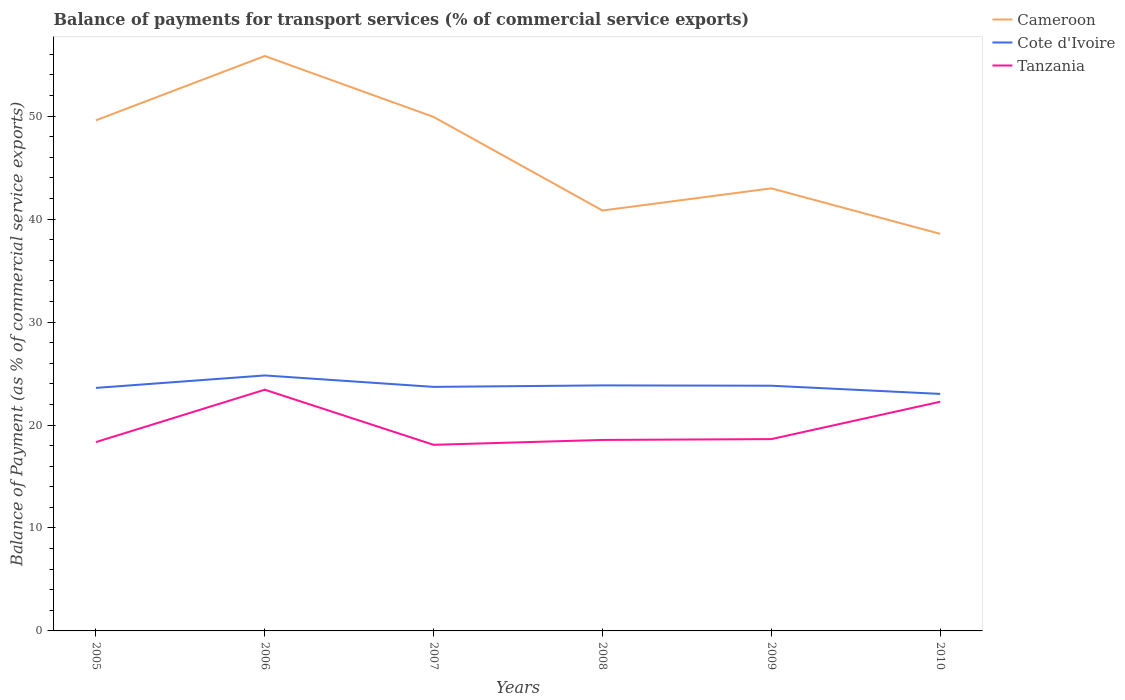Is the number of lines equal to the number of legend labels?
Your answer should be compact. Yes. Across all years, what is the maximum balance of payments for transport services in Cameroon?
Keep it short and to the point. 38.57. What is the total balance of payments for transport services in Cote d'Ivoire in the graph?
Offer a very short reply. 0.97. What is the difference between the highest and the second highest balance of payments for transport services in Cote d'Ivoire?
Provide a short and direct response. 1.79. Is the balance of payments for transport services in Cote d'Ivoire strictly greater than the balance of payments for transport services in Tanzania over the years?
Give a very brief answer. No. Are the values on the major ticks of Y-axis written in scientific E-notation?
Give a very brief answer. No. Does the graph contain grids?
Provide a succinct answer. No. Where does the legend appear in the graph?
Keep it short and to the point. Top right. How are the legend labels stacked?
Your answer should be very brief. Vertical. What is the title of the graph?
Ensure brevity in your answer.  Balance of payments for transport services (% of commercial service exports). What is the label or title of the Y-axis?
Your response must be concise. Balance of Payment (as % of commercial service exports). What is the Balance of Payment (as % of commercial service exports) of Cameroon in 2005?
Your answer should be very brief. 49.59. What is the Balance of Payment (as % of commercial service exports) in Cote d'Ivoire in 2005?
Offer a very short reply. 23.6. What is the Balance of Payment (as % of commercial service exports) in Tanzania in 2005?
Your answer should be very brief. 18.34. What is the Balance of Payment (as % of commercial service exports) of Cameroon in 2006?
Offer a terse response. 55.84. What is the Balance of Payment (as % of commercial service exports) of Cote d'Ivoire in 2006?
Make the answer very short. 24.81. What is the Balance of Payment (as % of commercial service exports) of Tanzania in 2006?
Ensure brevity in your answer.  23.43. What is the Balance of Payment (as % of commercial service exports) in Cameroon in 2007?
Provide a succinct answer. 49.92. What is the Balance of Payment (as % of commercial service exports) of Cote d'Ivoire in 2007?
Provide a succinct answer. 23.7. What is the Balance of Payment (as % of commercial service exports) in Tanzania in 2007?
Your answer should be compact. 18.08. What is the Balance of Payment (as % of commercial service exports) in Cameroon in 2008?
Make the answer very short. 40.83. What is the Balance of Payment (as % of commercial service exports) in Cote d'Ivoire in 2008?
Offer a very short reply. 23.85. What is the Balance of Payment (as % of commercial service exports) of Tanzania in 2008?
Ensure brevity in your answer.  18.55. What is the Balance of Payment (as % of commercial service exports) of Cameroon in 2009?
Your answer should be very brief. 42.99. What is the Balance of Payment (as % of commercial service exports) of Cote d'Ivoire in 2009?
Keep it short and to the point. 23.82. What is the Balance of Payment (as % of commercial service exports) in Tanzania in 2009?
Provide a short and direct response. 18.63. What is the Balance of Payment (as % of commercial service exports) of Cameroon in 2010?
Your answer should be very brief. 38.57. What is the Balance of Payment (as % of commercial service exports) of Cote d'Ivoire in 2010?
Your answer should be very brief. 23.02. What is the Balance of Payment (as % of commercial service exports) in Tanzania in 2010?
Keep it short and to the point. 22.26. Across all years, what is the maximum Balance of Payment (as % of commercial service exports) in Cameroon?
Provide a short and direct response. 55.84. Across all years, what is the maximum Balance of Payment (as % of commercial service exports) of Cote d'Ivoire?
Ensure brevity in your answer.  24.81. Across all years, what is the maximum Balance of Payment (as % of commercial service exports) in Tanzania?
Your response must be concise. 23.43. Across all years, what is the minimum Balance of Payment (as % of commercial service exports) in Cameroon?
Your answer should be compact. 38.57. Across all years, what is the minimum Balance of Payment (as % of commercial service exports) in Cote d'Ivoire?
Give a very brief answer. 23.02. Across all years, what is the minimum Balance of Payment (as % of commercial service exports) of Tanzania?
Offer a terse response. 18.08. What is the total Balance of Payment (as % of commercial service exports) in Cameroon in the graph?
Give a very brief answer. 277.74. What is the total Balance of Payment (as % of commercial service exports) in Cote d'Ivoire in the graph?
Offer a terse response. 142.81. What is the total Balance of Payment (as % of commercial service exports) of Tanzania in the graph?
Your answer should be very brief. 119.29. What is the difference between the Balance of Payment (as % of commercial service exports) of Cameroon in 2005 and that in 2006?
Make the answer very short. -6.24. What is the difference between the Balance of Payment (as % of commercial service exports) of Cote d'Ivoire in 2005 and that in 2006?
Give a very brief answer. -1.21. What is the difference between the Balance of Payment (as % of commercial service exports) of Tanzania in 2005 and that in 2006?
Your answer should be compact. -5.09. What is the difference between the Balance of Payment (as % of commercial service exports) in Cameroon in 2005 and that in 2007?
Give a very brief answer. -0.33. What is the difference between the Balance of Payment (as % of commercial service exports) in Cote d'Ivoire in 2005 and that in 2007?
Your answer should be very brief. -0.1. What is the difference between the Balance of Payment (as % of commercial service exports) in Tanzania in 2005 and that in 2007?
Your response must be concise. 0.27. What is the difference between the Balance of Payment (as % of commercial service exports) in Cameroon in 2005 and that in 2008?
Your answer should be very brief. 8.76. What is the difference between the Balance of Payment (as % of commercial service exports) of Cote d'Ivoire in 2005 and that in 2008?
Make the answer very short. -0.24. What is the difference between the Balance of Payment (as % of commercial service exports) in Tanzania in 2005 and that in 2008?
Make the answer very short. -0.21. What is the difference between the Balance of Payment (as % of commercial service exports) in Cameroon in 2005 and that in 2009?
Your answer should be very brief. 6.61. What is the difference between the Balance of Payment (as % of commercial service exports) in Cote d'Ivoire in 2005 and that in 2009?
Your answer should be very brief. -0.21. What is the difference between the Balance of Payment (as % of commercial service exports) of Tanzania in 2005 and that in 2009?
Offer a very short reply. -0.29. What is the difference between the Balance of Payment (as % of commercial service exports) of Cameroon in 2005 and that in 2010?
Give a very brief answer. 11.03. What is the difference between the Balance of Payment (as % of commercial service exports) in Cote d'Ivoire in 2005 and that in 2010?
Provide a succinct answer. 0.58. What is the difference between the Balance of Payment (as % of commercial service exports) of Tanzania in 2005 and that in 2010?
Keep it short and to the point. -3.92. What is the difference between the Balance of Payment (as % of commercial service exports) in Cameroon in 2006 and that in 2007?
Ensure brevity in your answer.  5.92. What is the difference between the Balance of Payment (as % of commercial service exports) of Cote d'Ivoire in 2006 and that in 2007?
Provide a short and direct response. 1.11. What is the difference between the Balance of Payment (as % of commercial service exports) of Tanzania in 2006 and that in 2007?
Your answer should be compact. 5.35. What is the difference between the Balance of Payment (as % of commercial service exports) of Cameroon in 2006 and that in 2008?
Keep it short and to the point. 15.01. What is the difference between the Balance of Payment (as % of commercial service exports) of Cote d'Ivoire in 2006 and that in 2008?
Offer a terse response. 0.97. What is the difference between the Balance of Payment (as % of commercial service exports) of Tanzania in 2006 and that in 2008?
Provide a short and direct response. 4.88. What is the difference between the Balance of Payment (as % of commercial service exports) in Cameroon in 2006 and that in 2009?
Your answer should be compact. 12.85. What is the difference between the Balance of Payment (as % of commercial service exports) of Cote d'Ivoire in 2006 and that in 2009?
Offer a terse response. 1. What is the difference between the Balance of Payment (as % of commercial service exports) in Tanzania in 2006 and that in 2009?
Your answer should be very brief. 4.8. What is the difference between the Balance of Payment (as % of commercial service exports) of Cameroon in 2006 and that in 2010?
Provide a short and direct response. 17.27. What is the difference between the Balance of Payment (as % of commercial service exports) in Cote d'Ivoire in 2006 and that in 2010?
Provide a short and direct response. 1.79. What is the difference between the Balance of Payment (as % of commercial service exports) of Tanzania in 2006 and that in 2010?
Give a very brief answer. 1.17. What is the difference between the Balance of Payment (as % of commercial service exports) of Cameroon in 2007 and that in 2008?
Your response must be concise. 9.09. What is the difference between the Balance of Payment (as % of commercial service exports) of Cote d'Ivoire in 2007 and that in 2008?
Make the answer very short. -0.14. What is the difference between the Balance of Payment (as % of commercial service exports) in Tanzania in 2007 and that in 2008?
Offer a very short reply. -0.47. What is the difference between the Balance of Payment (as % of commercial service exports) in Cameroon in 2007 and that in 2009?
Ensure brevity in your answer.  6.94. What is the difference between the Balance of Payment (as % of commercial service exports) of Cote d'Ivoire in 2007 and that in 2009?
Your answer should be very brief. -0.11. What is the difference between the Balance of Payment (as % of commercial service exports) in Tanzania in 2007 and that in 2009?
Offer a terse response. -0.55. What is the difference between the Balance of Payment (as % of commercial service exports) in Cameroon in 2007 and that in 2010?
Offer a very short reply. 11.36. What is the difference between the Balance of Payment (as % of commercial service exports) of Cote d'Ivoire in 2007 and that in 2010?
Make the answer very short. 0.68. What is the difference between the Balance of Payment (as % of commercial service exports) of Tanzania in 2007 and that in 2010?
Your answer should be very brief. -4.18. What is the difference between the Balance of Payment (as % of commercial service exports) of Cameroon in 2008 and that in 2009?
Your answer should be very brief. -2.15. What is the difference between the Balance of Payment (as % of commercial service exports) in Cote d'Ivoire in 2008 and that in 2009?
Keep it short and to the point. 0.03. What is the difference between the Balance of Payment (as % of commercial service exports) in Tanzania in 2008 and that in 2009?
Offer a terse response. -0.08. What is the difference between the Balance of Payment (as % of commercial service exports) in Cameroon in 2008 and that in 2010?
Your answer should be very brief. 2.27. What is the difference between the Balance of Payment (as % of commercial service exports) in Cote d'Ivoire in 2008 and that in 2010?
Offer a terse response. 0.83. What is the difference between the Balance of Payment (as % of commercial service exports) in Tanzania in 2008 and that in 2010?
Keep it short and to the point. -3.71. What is the difference between the Balance of Payment (as % of commercial service exports) in Cameroon in 2009 and that in 2010?
Ensure brevity in your answer.  4.42. What is the difference between the Balance of Payment (as % of commercial service exports) of Cote d'Ivoire in 2009 and that in 2010?
Offer a very short reply. 0.79. What is the difference between the Balance of Payment (as % of commercial service exports) of Tanzania in 2009 and that in 2010?
Offer a very short reply. -3.63. What is the difference between the Balance of Payment (as % of commercial service exports) of Cameroon in 2005 and the Balance of Payment (as % of commercial service exports) of Cote d'Ivoire in 2006?
Provide a short and direct response. 24.78. What is the difference between the Balance of Payment (as % of commercial service exports) of Cameroon in 2005 and the Balance of Payment (as % of commercial service exports) of Tanzania in 2006?
Offer a very short reply. 26.17. What is the difference between the Balance of Payment (as % of commercial service exports) of Cote d'Ivoire in 2005 and the Balance of Payment (as % of commercial service exports) of Tanzania in 2006?
Keep it short and to the point. 0.17. What is the difference between the Balance of Payment (as % of commercial service exports) in Cameroon in 2005 and the Balance of Payment (as % of commercial service exports) in Cote d'Ivoire in 2007?
Make the answer very short. 25.89. What is the difference between the Balance of Payment (as % of commercial service exports) of Cameroon in 2005 and the Balance of Payment (as % of commercial service exports) of Tanzania in 2007?
Provide a short and direct response. 31.52. What is the difference between the Balance of Payment (as % of commercial service exports) of Cote d'Ivoire in 2005 and the Balance of Payment (as % of commercial service exports) of Tanzania in 2007?
Make the answer very short. 5.53. What is the difference between the Balance of Payment (as % of commercial service exports) in Cameroon in 2005 and the Balance of Payment (as % of commercial service exports) in Cote d'Ivoire in 2008?
Provide a short and direct response. 25.75. What is the difference between the Balance of Payment (as % of commercial service exports) of Cameroon in 2005 and the Balance of Payment (as % of commercial service exports) of Tanzania in 2008?
Your response must be concise. 31.04. What is the difference between the Balance of Payment (as % of commercial service exports) in Cote d'Ivoire in 2005 and the Balance of Payment (as % of commercial service exports) in Tanzania in 2008?
Offer a very short reply. 5.05. What is the difference between the Balance of Payment (as % of commercial service exports) of Cameroon in 2005 and the Balance of Payment (as % of commercial service exports) of Cote d'Ivoire in 2009?
Your answer should be very brief. 25.78. What is the difference between the Balance of Payment (as % of commercial service exports) of Cameroon in 2005 and the Balance of Payment (as % of commercial service exports) of Tanzania in 2009?
Offer a very short reply. 30.96. What is the difference between the Balance of Payment (as % of commercial service exports) in Cote d'Ivoire in 2005 and the Balance of Payment (as % of commercial service exports) in Tanzania in 2009?
Ensure brevity in your answer.  4.97. What is the difference between the Balance of Payment (as % of commercial service exports) of Cameroon in 2005 and the Balance of Payment (as % of commercial service exports) of Cote d'Ivoire in 2010?
Ensure brevity in your answer.  26.57. What is the difference between the Balance of Payment (as % of commercial service exports) in Cameroon in 2005 and the Balance of Payment (as % of commercial service exports) in Tanzania in 2010?
Offer a very short reply. 27.33. What is the difference between the Balance of Payment (as % of commercial service exports) in Cote d'Ivoire in 2005 and the Balance of Payment (as % of commercial service exports) in Tanzania in 2010?
Offer a terse response. 1.34. What is the difference between the Balance of Payment (as % of commercial service exports) of Cameroon in 2006 and the Balance of Payment (as % of commercial service exports) of Cote d'Ivoire in 2007?
Keep it short and to the point. 32.14. What is the difference between the Balance of Payment (as % of commercial service exports) of Cameroon in 2006 and the Balance of Payment (as % of commercial service exports) of Tanzania in 2007?
Offer a terse response. 37.76. What is the difference between the Balance of Payment (as % of commercial service exports) in Cote d'Ivoire in 2006 and the Balance of Payment (as % of commercial service exports) in Tanzania in 2007?
Provide a succinct answer. 6.74. What is the difference between the Balance of Payment (as % of commercial service exports) in Cameroon in 2006 and the Balance of Payment (as % of commercial service exports) in Cote d'Ivoire in 2008?
Your response must be concise. 31.99. What is the difference between the Balance of Payment (as % of commercial service exports) in Cameroon in 2006 and the Balance of Payment (as % of commercial service exports) in Tanzania in 2008?
Give a very brief answer. 37.29. What is the difference between the Balance of Payment (as % of commercial service exports) in Cote d'Ivoire in 2006 and the Balance of Payment (as % of commercial service exports) in Tanzania in 2008?
Offer a very short reply. 6.26. What is the difference between the Balance of Payment (as % of commercial service exports) in Cameroon in 2006 and the Balance of Payment (as % of commercial service exports) in Cote d'Ivoire in 2009?
Provide a short and direct response. 32.02. What is the difference between the Balance of Payment (as % of commercial service exports) of Cameroon in 2006 and the Balance of Payment (as % of commercial service exports) of Tanzania in 2009?
Your answer should be compact. 37.21. What is the difference between the Balance of Payment (as % of commercial service exports) of Cote d'Ivoire in 2006 and the Balance of Payment (as % of commercial service exports) of Tanzania in 2009?
Your answer should be very brief. 6.18. What is the difference between the Balance of Payment (as % of commercial service exports) of Cameroon in 2006 and the Balance of Payment (as % of commercial service exports) of Cote d'Ivoire in 2010?
Ensure brevity in your answer.  32.82. What is the difference between the Balance of Payment (as % of commercial service exports) of Cameroon in 2006 and the Balance of Payment (as % of commercial service exports) of Tanzania in 2010?
Make the answer very short. 33.58. What is the difference between the Balance of Payment (as % of commercial service exports) in Cote d'Ivoire in 2006 and the Balance of Payment (as % of commercial service exports) in Tanzania in 2010?
Your response must be concise. 2.55. What is the difference between the Balance of Payment (as % of commercial service exports) of Cameroon in 2007 and the Balance of Payment (as % of commercial service exports) of Cote d'Ivoire in 2008?
Your response must be concise. 26.07. What is the difference between the Balance of Payment (as % of commercial service exports) in Cameroon in 2007 and the Balance of Payment (as % of commercial service exports) in Tanzania in 2008?
Offer a terse response. 31.37. What is the difference between the Balance of Payment (as % of commercial service exports) in Cote d'Ivoire in 2007 and the Balance of Payment (as % of commercial service exports) in Tanzania in 2008?
Ensure brevity in your answer.  5.15. What is the difference between the Balance of Payment (as % of commercial service exports) in Cameroon in 2007 and the Balance of Payment (as % of commercial service exports) in Cote d'Ivoire in 2009?
Your response must be concise. 26.11. What is the difference between the Balance of Payment (as % of commercial service exports) in Cameroon in 2007 and the Balance of Payment (as % of commercial service exports) in Tanzania in 2009?
Your answer should be compact. 31.29. What is the difference between the Balance of Payment (as % of commercial service exports) in Cote d'Ivoire in 2007 and the Balance of Payment (as % of commercial service exports) in Tanzania in 2009?
Ensure brevity in your answer.  5.07. What is the difference between the Balance of Payment (as % of commercial service exports) in Cameroon in 2007 and the Balance of Payment (as % of commercial service exports) in Cote d'Ivoire in 2010?
Offer a very short reply. 26.9. What is the difference between the Balance of Payment (as % of commercial service exports) in Cameroon in 2007 and the Balance of Payment (as % of commercial service exports) in Tanzania in 2010?
Make the answer very short. 27.66. What is the difference between the Balance of Payment (as % of commercial service exports) in Cote d'Ivoire in 2007 and the Balance of Payment (as % of commercial service exports) in Tanzania in 2010?
Your answer should be very brief. 1.44. What is the difference between the Balance of Payment (as % of commercial service exports) in Cameroon in 2008 and the Balance of Payment (as % of commercial service exports) in Cote d'Ivoire in 2009?
Give a very brief answer. 17.02. What is the difference between the Balance of Payment (as % of commercial service exports) of Cameroon in 2008 and the Balance of Payment (as % of commercial service exports) of Tanzania in 2009?
Your response must be concise. 22.2. What is the difference between the Balance of Payment (as % of commercial service exports) of Cote d'Ivoire in 2008 and the Balance of Payment (as % of commercial service exports) of Tanzania in 2009?
Ensure brevity in your answer.  5.22. What is the difference between the Balance of Payment (as % of commercial service exports) of Cameroon in 2008 and the Balance of Payment (as % of commercial service exports) of Cote d'Ivoire in 2010?
Provide a succinct answer. 17.81. What is the difference between the Balance of Payment (as % of commercial service exports) of Cameroon in 2008 and the Balance of Payment (as % of commercial service exports) of Tanzania in 2010?
Ensure brevity in your answer.  18.57. What is the difference between the Balance of Payment (as % of commercial service exports) of Cote d'Ivoire in 2008 and the Balance of Payment (as % of commercial service exports) of Tanzania in 2010?
Provide a succinct answer. 1.59. What is the difference between the Balance of Payment (as % of commercial service exports) of Cameroon in 2009 and the Balance of Payment (as % of commercial service exports) of Cote d'Ivoire in 2010?
Provide a short and direct response. 19.96. What is the difference between the Balance of Payment (as % of commercial service exports) in Cameroon in 2009 and the Balance of Payment (as % of commercial service exports) in Tanzania in 2010?
Offer a terse response. 20.73. What is the difference between the Balance of Payment (as % of commercial service exports) in Cote d'Ivoire in 2009 and the Balance of Payment (as % of commercial service exports) in Tanzania in 2010?
Your answer should be very brief. 1.56. What is the average Balance of Payment (as % of commercial service exports) of Cameroon per year?
Provide a short and direct response. 46.29. What is the average Balance of Payment (as % of commercial service exports) in Cote d'Ivoire per year?
Keep it short and to the point. 23.8. What is the average Balance of Payment (as % of commercial service exports) in Tanzania per year?
Offer a terse response. 19.88. In the year 2005, what is the difference between the Balance of Payment (as % of commercial service exports) in Cameroon and Balance of Payment (as % of commercial service exports) in Cote d'Ivoire?
Your answer should be very brief. 25.99. In the year 2005, what is the difference between the Balance of Payment (as % of commercial service exports) of Cameroon and Balance of Payment (as % of commercial service exports) of Tanzania?
Your response must be concise. 31.25. In the year 2005, what is the difference between the Balance of Payment (as % of commercial service exports) in Cote d'Ivoire and Balance of Payment (as % of commercial service exports) in Tanzania?
Ensure brevity in your answer.  5.26. In the year 2006, what is the difference between the Balance of Payment (as % of commercial service exports) in Cameroon and Balance of Payment (as % of commercial service exports) in Cote d'Ivoire?
Give a very brief answer. 31.02. In the year 2006, what is the difference between the Balance of Payment (as % of commercial service exports) in Cameroon and Balance of Payment (as % of commercial service exports) in Tanzania?
Your answer should be very brief. 32.41. In the year 2006, what is the difference between the Balance of Payment (as % of commercial service exports) in Cote d'Ivoire and Balance of Payment (as % of commercial service exports) in Tanzania?
Your answer should be compact. 1.39. In the year 2007, what is the difference between the Balance of Payment (as % of commercial service exports) in Cameroon and Balance of Payment (as % of commercial service exports) in Cote d'Ivoire?
Offer a terse response. 26.22. In the year 2007, what is the difference between the Balance of Payment (as % of commercial service exports) of Cameroon and Balance of Payment (as % of commercial service exports) of Tanzania?
Make the answer very short. 31.85. In the year 2007, what is the difference between the Balance of Payment (as % of commercial service exports) of Cote d'Ivoire and Balance of Payment (as % of commercial service exports) of Tanzania?
Your response must be concise. 5.63. In the year 2008, what is the difference between the Balance of Payment (as % of commercial service exports) of Cameroon and Balance of Payment (as % of commercial service exports) of Cote d'Ivoire?
Your answer should be very brief. 16.99. In the year 2008, what is the difference between the Balance of Payment (as % of commercial service exports) of Cameroon and Balance of Payment (as % of commercial service exports) of Tanzania?
Offer a very short reply. 22.28. In the year 2008, what is the difference between the Balance of Payment (as % of commercial service exports) of Cote d'Ivoire and Balance of Payment (as % of commercial service exports) of Tanzania?
Give a very brief answer. 5.3. In the year 2009, what is the difference between the Balance of Payment (as % of commercial service exports) of Cameroon and Balance of Payment (as % of commercial service exports) of Cote d'Ivoire?
Make the answer very short. 19.17. In the year 2009, what is the difference between the Balance of Payment (as % of commercial service exports) in Cameroon and Balance of Payment (as % of commercial service exports) in Tanzania?
Your answer should be compact. 24.35. In the year 2009, what is the difference between the Balance of Payment (as % of commercial service exports) of Cote d'Ivoire and Balance of Payment (as % of commercial service exports) of Tanzania?
Your answer should be very brief. 5.18. In the year 2010, what is the difference between the Balance of Payment (as % of commercial service exports) of Cameroon and Balance of Payment (as % of commercial service exports) of Cote d'Ivoire?
Offer a terse response. 15.55. In the year 2010, what is the difference between the Balance of Payment (as % of commercial service exports) in Cameroon and Balance of Payment (as % of commercial service exports) in Tanzania?
Your answer should be compact. 16.31. In the year 2010, what is the difference between the Balance of Payment (as % of commercial service exports) in Cote d'Ivoire and Balance of Payment (as % of commercial service exports) in Tanzania?
Give a very brief answer. 0.76. What is the ratio of the Balance of Payment (as % of commercial service exports) in Cameroon in 2005 to that in 2006?
Your response must be concise. 0.89. What is the ratio of the Balance of Payment (as % of commercial service exports) of Cote d'Ivoire in 2005 to that in 2006?
Offer a terse response. 0.95. What is the ratio of the Balance of Payment (as % of commercial service exports) in Tanzania in 2005 to that in 2006?
Offer a very short reply. 0.78. What is the ratio of the Balance of Payment (as % of commercial service exports) in Tanzania in 2005 to that in 2007?
Provide a short and direct response. 1.01. What is the ratio of the Balance of Payment (as % of commercial service exports) of Cameroon in 2005 to that in 2008?
Offer a very short reply. 1.21. What is the ratio of the Balance of Payment (as % of commercial service exports) in Cote d'Ivoire in 2005 to that in 2008?
Your answer should be very brief. 0.99. What is the ratio of the Balance of Payment (as % of commercial service exports) in Tanzania in 2005 to that in 2008?
Give a very brief answer. 0.99. What is the ratio of the Balance of Payment (as % of commercial service exports) of Cameroon in 2005 to that in 2009?
Give a very brief answer. 1.15. What is the ratio of the Balance of Payment (as % of commercial service exports) in Tanzania in 2005 to that in 2009?
Your answer should be compact. 0.98. What is the ratio of the Balance of Payment (as % of commercial service exports) in Cameroon in 2005 to that in 2010?
Your response must be concise. 1.29. What is the ratio of the Balance of Payment (as % of commercial service exports) in Cote d'Ivoire in 2005 to that in 2010?
Your answer should be compact. 1.03. What is the ratio of the Balance of Payment (as % of commercial service exports) of Tanzania in 2005 to that in 2010?
Keep it short and to the point. 0.82. What is the ratio of the Balance of Payment (as % of commercial service exports) of Cameroon in 2006 to that in 2007?
Ensure brevity in your answer.  1.12. What is the ratio of the Balance of Payment (as % of commercial service exports) in Cote d'Ivoire in 2006 to that in 2007?
Your response must be concise. 1.05. What is the ratio of the Balance of Payment (as % of commercial service exports) in Tanzania in 2006 to that in 2007?
Your answer should be very brief. 1.3. What is the ratio of the Balance of Payment (as % of commercial service exports) in Cameroon in 2006 to that in 2008?
Offer a terse response. 1.37. What is the ratio of the Balance of Payment (as % of commercial service exports) in Cote d'Ivoire in 2006 to that in 2008?
Keep it short and to the point. 1.04. What is the ratio of the Balance of Payment (as % of commercial service exports) in Tanzania in 2006 to that in 2008?
Offer a very short reply. 1.26. What is the ratio of the Balance of Payment (as % of commercial service exports) in Cameroon in 2006 to that in 2009?
Your answer should be compact. 1.3. What is the ratio of the Balance of Payment (as % of commercial service exports) in Cote d'Ivoire in 2006 to that in 2009?
Keep it short and to the point. 1.04. What is the ratio of the Balance of Payment (as % of commercial service exports) in Tanzania in 2006 to that in 2009?
Your answer should be very brief. 1.26. What is the ratio of the Balance of Payment (as % of commercial service exports) of Cameroon in 2006 to that in 2010?
Offer a very short reply. 1.45. What is the ratio of the Balance of Payment (as % of commercial service exports) of Cote d'Ivoire in 2006 to that in 2010?
Provide a short and direct response. 1.08. What is the ratio of the Balance of Payment (as % of commercial service exports) in Tanzania in 2006 to that in 2010?
Your response must be concise. 1.05. What is the ratio of the Balance of Payment (as % of commercial service exports) in Cameroon in 2007 to that in 2008?
Keep it short and to the point. 1.22. What is the ratio of the Balance of Payment (as % of commercial service exports) in Cote d'Ivoire in 2007 to that in 2008?
Ensure brevity in your answer.  0.99. What is the ratio of the Balance of Payment (as % of commercial service exports) of Tanzania in 2007 to that in 2008?
Provide a succinct answer. 0.97. What is the ratio of the Balance of Payment (as % of commercial service exports) in Cameroon in 2007 to that in 2009?
Give a very brief answer. 1.16. What is the ratio of the Balance of Payment (as % of commercial service exports) of Cote d'Ivoire in 2007 to that in 2009?
Keep it short and to the point. 1. What is the ratio of the Balance of Payment (as % of commercial service exports) of Tanzania in 2007 to that in 2009?
Your answer should be compact. 0.97. What is the ratio of the Balance of Payment (as % of commercial service exports) of Cameroon in 2007 to that in 2010?
Provide a succinct answer. 1.29. What is the ratio of the Balance of Payment (as % of commercial service exports) in Cote d'Ivoire in 2007 to that in 2010?
Your answer should be compact. 1.03. What is the ratio of the Balance of Payment (as % of commercial service exports) in Tanzania in 2007 to that in 2010?
Offer a very short reply. 0.81. What is the ratio of the Balance of Payment (as % of commercial service exports) of Cameroon in 2008 to that in 2009?
Provide a short and direct response. 0.95. What is the ratio of the Balance of Payment (as % of commercial service exports) of Cote d'Ivoire in 2008 to that in 2009?
Your response must be concise. 1. What is the ratio of the Balance of Payment (as % of commercial service exports) of Cameroon in 2008 to that in 2010?
Make the answer very short. 1.06. What is the ratio of the Balance of Payment (as % of commercial service exports) of Cote d'Ivoire in 2008 to that in 2010?
Make the answer very short. 1.04. What is the ratio of the Balance of Payment (as % of commercial service exports) in Cameroon in 2009 to that in 2010?
Provide a succinct answer. 1.11. What is the ratio of the Balance of Payment (as % of commercial service exports) in Cote d'Ivoire in 2009 to that in 2010?
Provide a succinct answer. 1.03. What is the ratio of the Balance of Payment (as % of commercial service exports) of Tanzania in 2009 to that in 2010?
Keep it short and to the point. 0.84. What is the difference between the highest and the second highest Balance of Payment (as % of commercial service exports) in Cameroon?
Make the answer very short. 5.92. What is the difference between the highest and the second highest Balance of Payment (as % of commercial service exports) of Cote d'Ivoire?
Offer a terse response. 0.97. What is the difference between the highest and the second highest Balance of Payment (as % of commercial service exports) of Tanzania?
Provide a succinct answer. 1.17. What is the difference between the highest and the lowest Balance of Payment (as % of commercial service exports) in Cameroon?
Offer a terse response. 17.27. What is the difference between the highest and the lowest Balance of Payment (as % of commercial service exports) of Cote d'Ivoire?
Offer a terse response. 1.79. What is the difference between the highest and the lowest Balance of Payment (as % of commercial service exports) in Tanzania?
Provide a succinct answer. 5.35. 